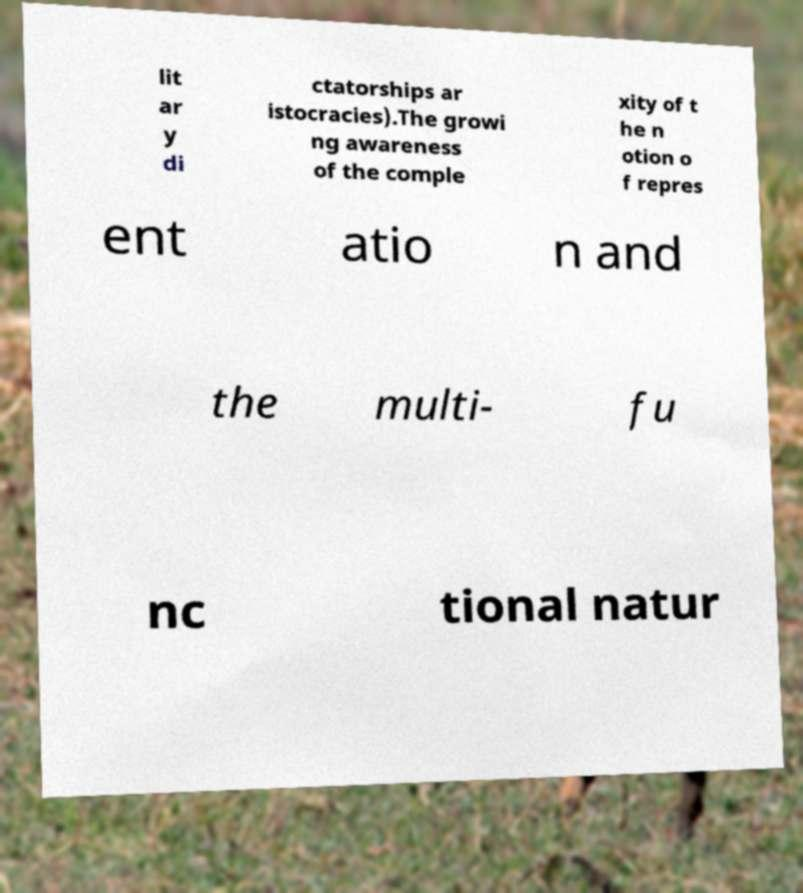Could you assist in decoding the text presented in this image and type it out clearly? lit ar y di ctatorships ar istocracies).The growi ng awareness of the comple xity of t he n otion o f repres ent atio n and the multi- fu nc tional natur 